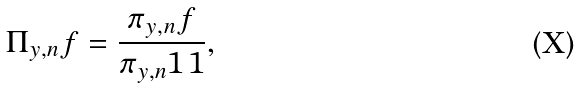<formula> <loc_0><loc_0><loc_500><loc_500>\Pi _ { y , n } f = \frac { \pi _ { y , n } f } { \pi _ { y , n } 1 \, 1 } ,</formula> 